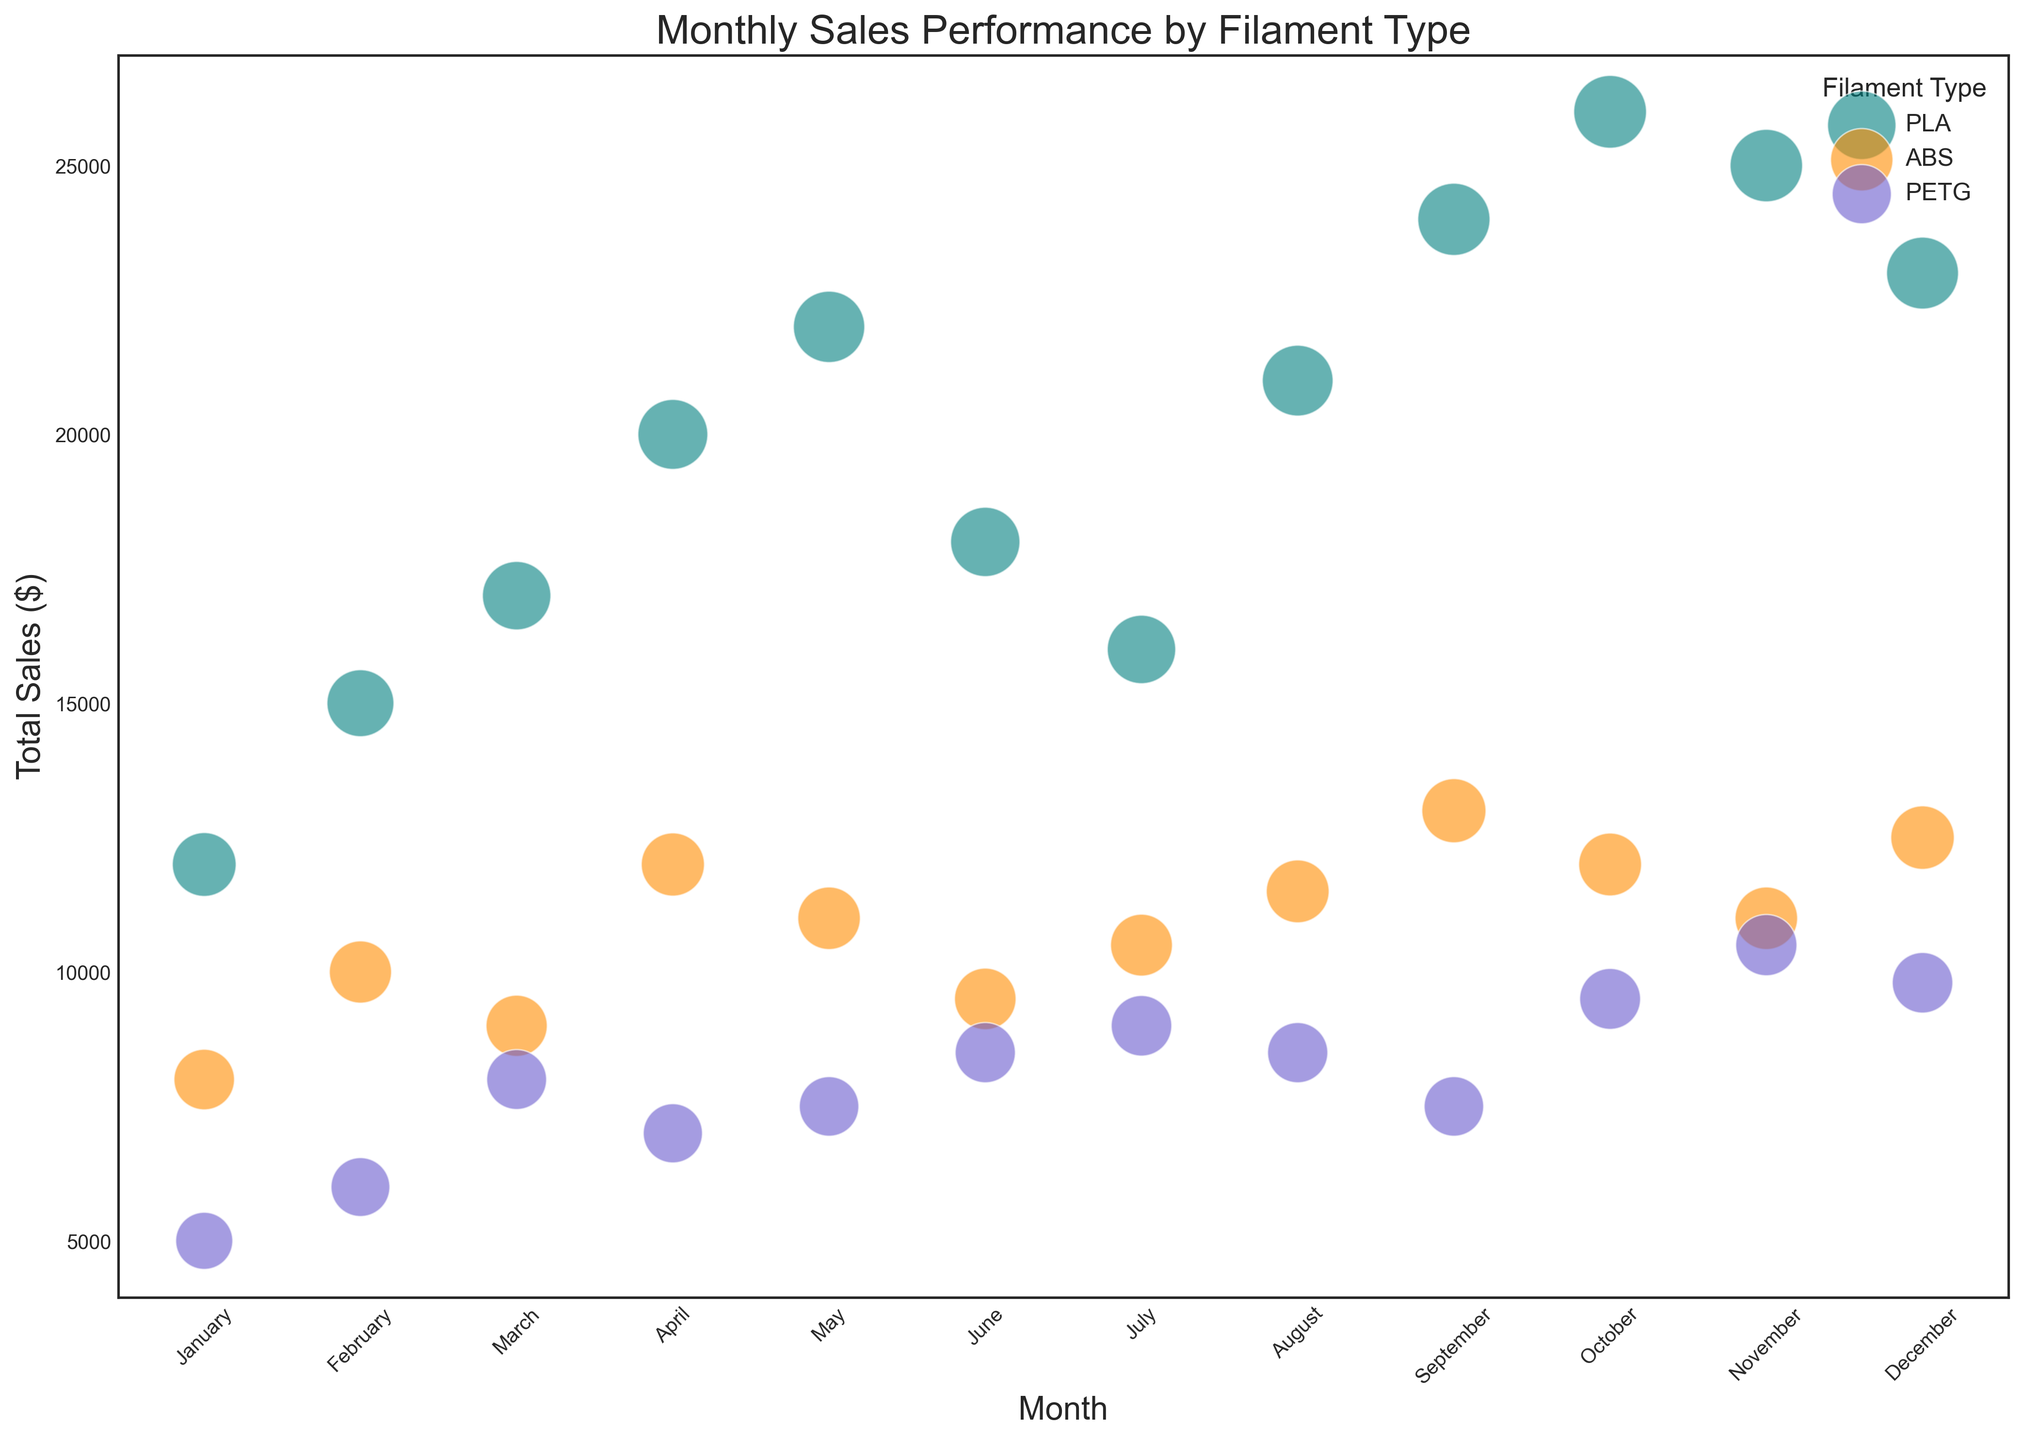What is the filament type with the highest sales in January? To find the filament type with the highest sales in January, examine the total sales for each filament type in January. PLA has sales of $12,000, ABS has sales of $8,000, and PETG has sales of $5,000. PLA has the highest sales.
Answer: PLA Which month has the highest total sales for PLA filament? Look at the total sales of PLA filament for each month. October has the highest total sales for PLA filament with $26,000.
Answer: October What is the total sales difference between ABS and PETG filaments in February? In February, the total sales for ABS is $10,000, and for PETG, it is $6,000. The difference is $10,000 - $6,000 = $4,000.
Answer: $4,000 Which months have a higher total sales for ABS filament than the previous month? To determine this, compare the total sales of ABS filament month-over-month. ABS sales in January is $8,000, in February is $10,000 (higher), in March is $9,000 (lower), in April is $12,000 (higher), in May is $11,000 (lower), in June is $9,500 (lower), in July is $10,500 (higher), in August is $11,500 (higher), in September is $13,000 (higher), in October is $12,000 (lower), in November is $11,000 (lower), in December is $12,500 (higher). Therefore, February, April, July, August, and September have higher total sales than the previous month.
Answer: February, April, July, August, September, December What is the average unit price for PETG filament in August? Look up the average unit price for PETG filament in August, which is directly provided as $50.
Answer: $50 Which filament type consistently shows a steady increase in total sales each month from January to May? Examine the total sales for each filament type from January to May. PLA's sales are as follows: $12,000, $15,000, $17,000, $20,000, $22,000. ABS and PETG do not show a consistent increase each month. PLA shows a steady increase.
Answer: PLA Is there any month where the average unit price of ABS filament is higher than that of PETG filament? Compare the average unit price of ABS with PETG for each month. In all months, ABS's average unit price is less than or equal to PETG's price. Therefore, there is no such month.
Answer: No Which month has the highest overall sales and what might be the contributing factor? Check the total sales of each month by summing up sales of all filament types: October shows the highest total with $47,500. The contributing factor could be the high sales of PLA ($26,000).
Answer: October What is the total number of PLA units sold between January and June? Sum the number of units sold from January to June for PLA. The numbers are 400, 500, 550, 650, 700, and 600, making the total 400 + 500 + 550 + 650 + 700 + 600 = 3,400.
Answer: 3,400 Was there any month where PETG had the highest total sales compared to PLA and ABS? Check the total sales of PETG and compare them with PLA and ABS for each month. In all listed months, PLA or ABS have higher sales than PETG.
Answer: No 